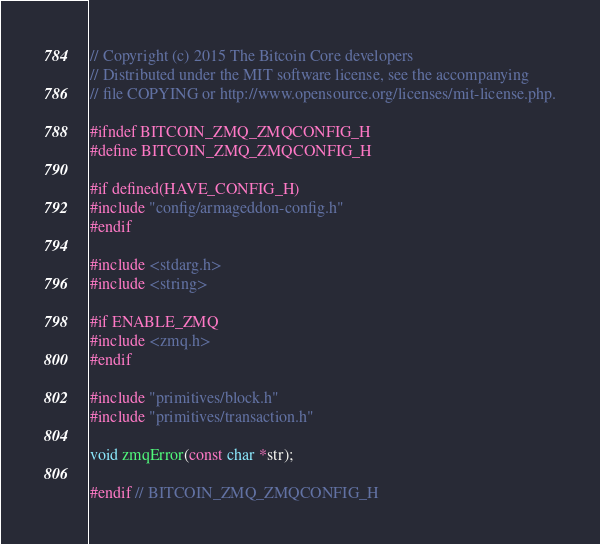<code> <loc_0><loc_0><loc_500><loc_500><_C_>// Copyright (c) 2015 The Bitcoin Core developers
// Distributed under the MIT software license, see the accompanying
// file COPYING or http://www.opensource.org/licenses/mit-license.php.

#ifndef BITCOIN_ZMQ_ZMQCONFIG_H
#define BITCOIN_ZMQ_ZMQCONFIG_H

#if defined(HAVE_CONFIG_H)
#include "config/armageddon-config.h"
#endif

#include <stdarg.h>
#include <string>

#if ENABLE_ZMQ
#include <zmq.h>
#endif

#include "primitives/block.h"
#include "primitives/transaction.h"

void zmqError(const char *str);

#endif // BITCOIN_ZMQ_ZMQCONFIG_H
</code> 